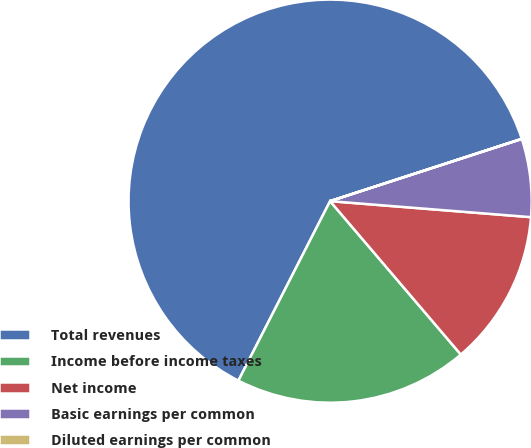<chart> <loc_0><loc_0><loc_500><loc_500><pie_chart><fcel>Total revenues<fcel>Income before income taxes<fcel>Net income<fcel>Basic earnings per common<fcel>Diluted earnings per common<nl><fcel>62.48%<fcel>18.75%<fcel>12.5%<fcel>6.26%<fcel>0.01%<nl></chart> 